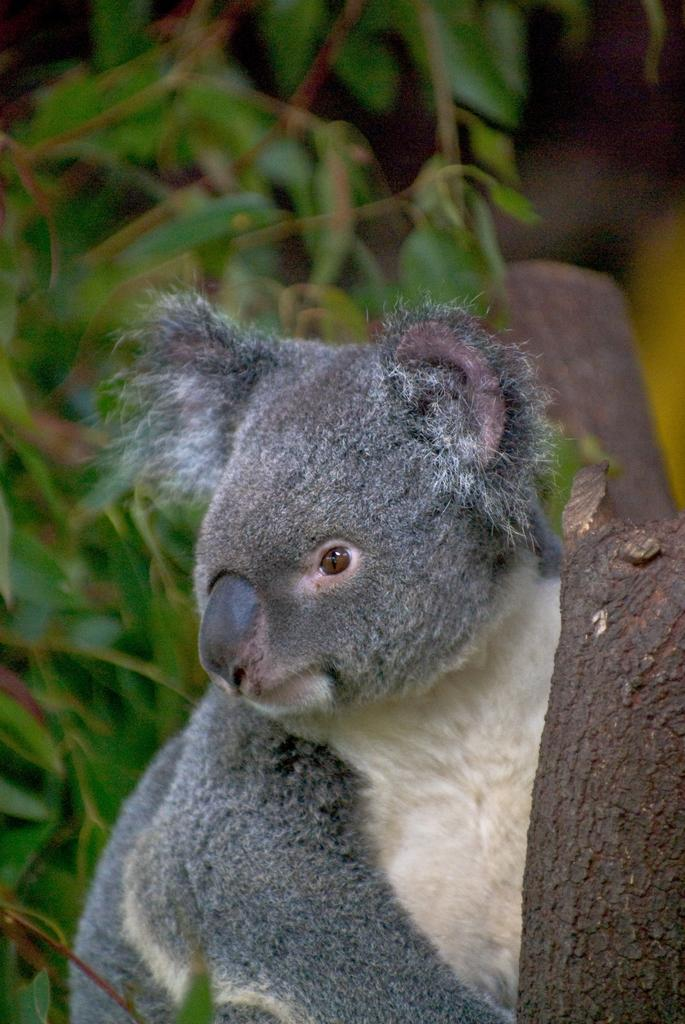What type of animal is in the image? There is an animal in the image, but the specific type cannot be determined from the provided facts. Where is the animal located in relation to the tree trunk? The animal is near a tree trunk in the image. What can be seen in the background of the image? There are trees in the background of the image. What type of map is the animal offering to the tree in the image? There is no map present in the image, and the animal is not offering anything to the tree. 